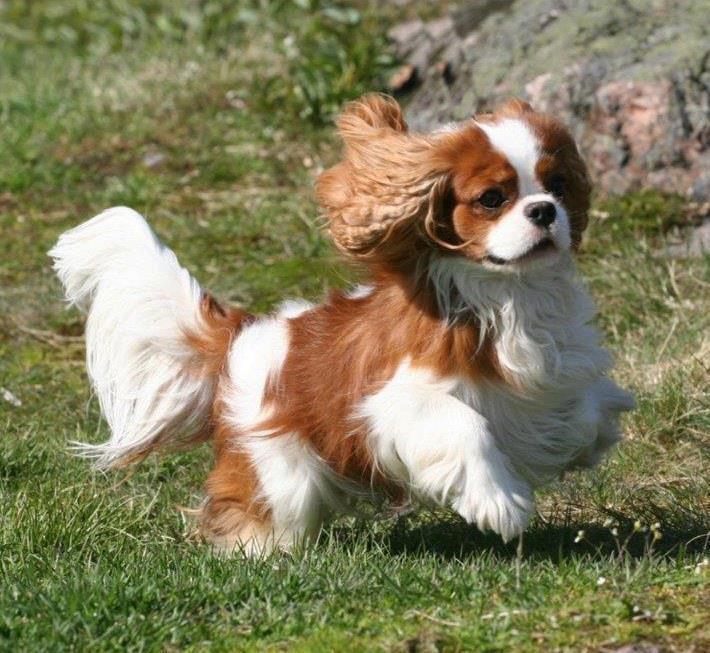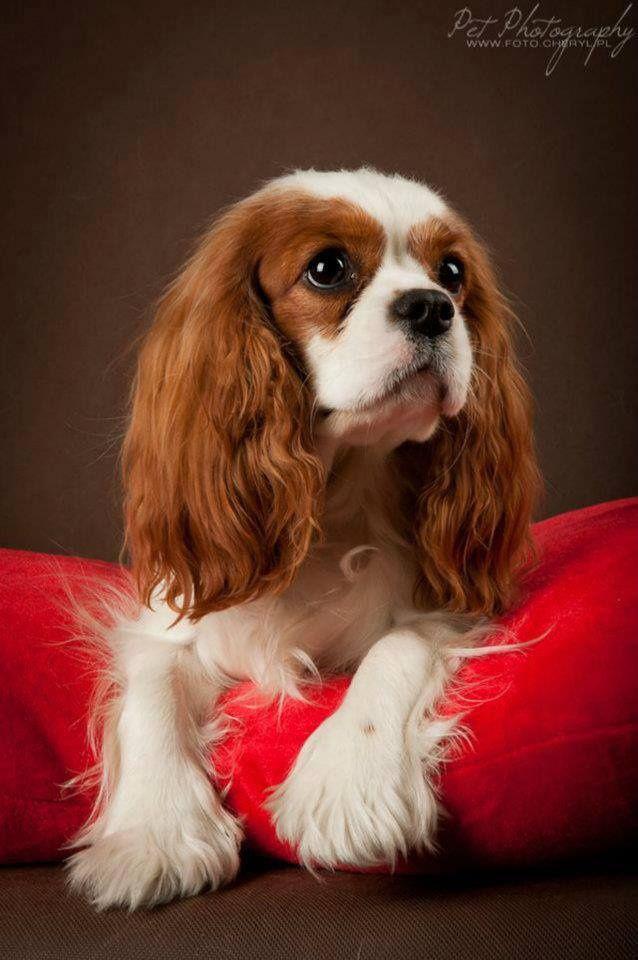The first image is the image on the left, the second image is the image on the right. Analyze the images presented: Is the assertion "At least one King Charles puppy is shown next to their mother." valid? Answer yes or no. No. The first image is the image on the left, the second image is the image on the right. Considering the images on both sides, is "An image contains at least two dogs." valid? Answer yes or no. No. 